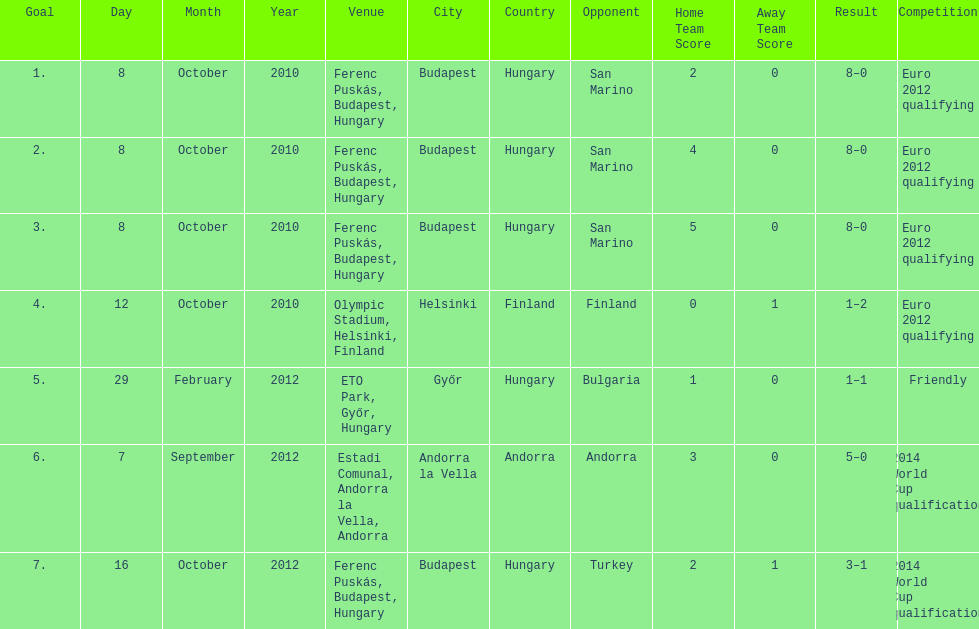In what year did ádám szalai make his next international goal after 2010? 2012. 